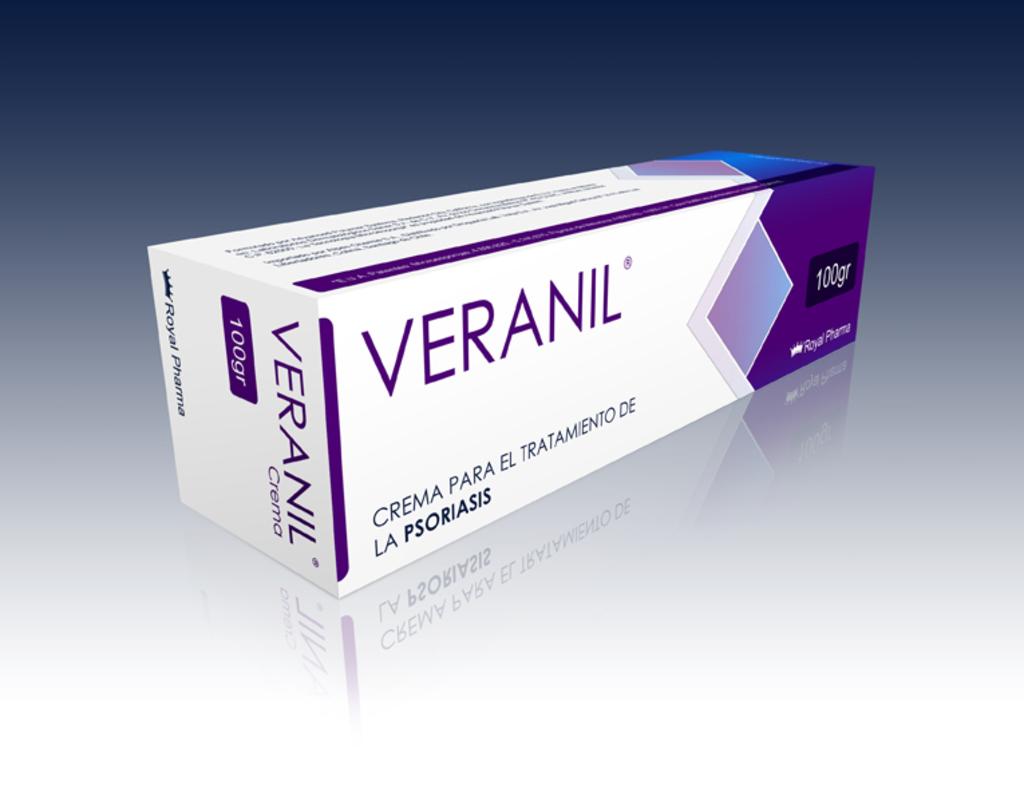What is this suppose to cure?
Your response must be concise. Psoriasis. What is the brand name?
Make the answer very short. Veranil. 